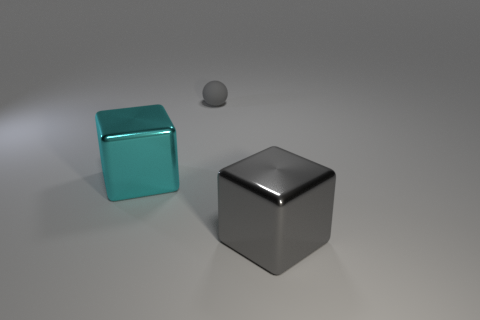Add 1 tiny brown rubber things. How many objects exist? 4 Subtract all spheres. How many objects are left? 2 Add 1 cyan blocks. How many cyan blocks exist? 2 Subtract 1 gray spheres. How many objects are left? 2 Subtract all gray metal cubes. Subtract all brown shiny objects. How many objects are left? 2 Add 1 spheres. How many spheres are left? 2 